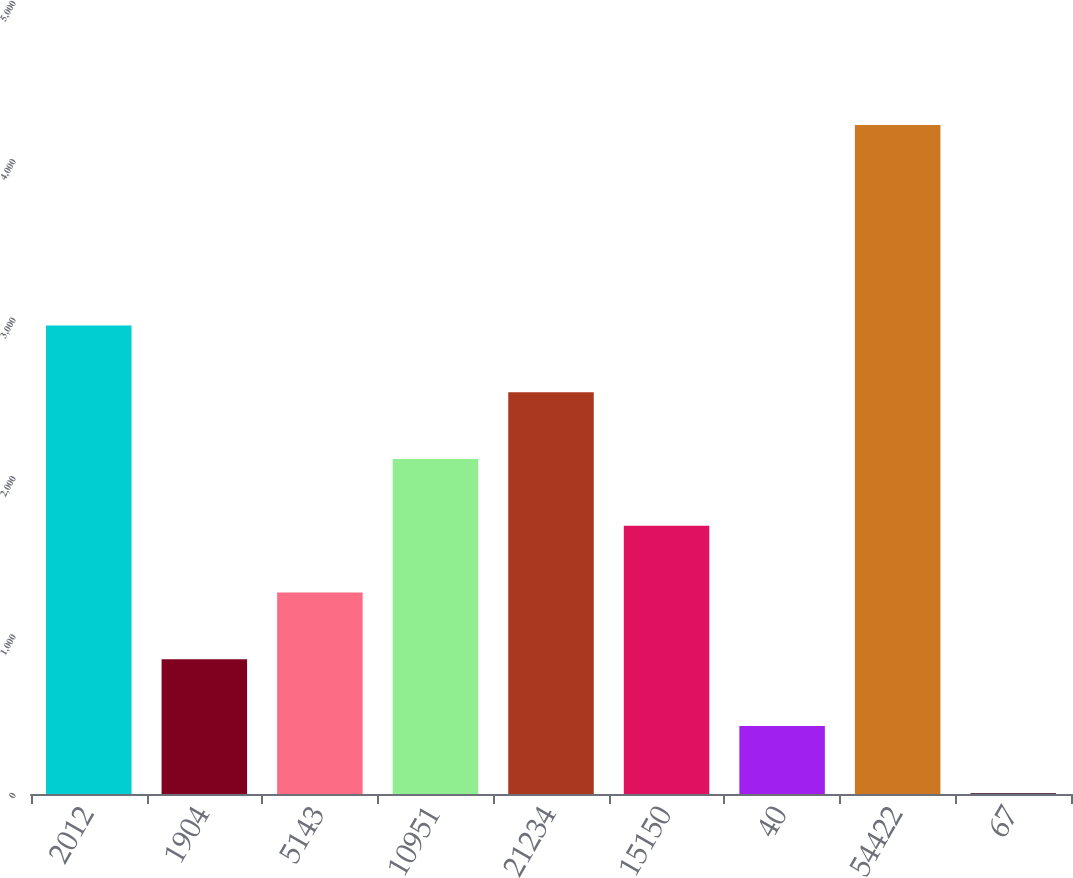Convert chart. <chart><loc_0><loc_0><loc_500><loc_500><bar_chart><fcel>2012<fcel>1904<fcel>5143<fcel>10951<fcel>21234<fcel>15150<fcel>40<fcel>54422<fcel>67<nl><fcel>2958.45<fcel>850.2<fcel>1271.85<fcel>2115.15<fcel>2536.8<fcel>1693.5<fcel>428.55<fcel>4223.4<fcel>6.9<nl></chart> 